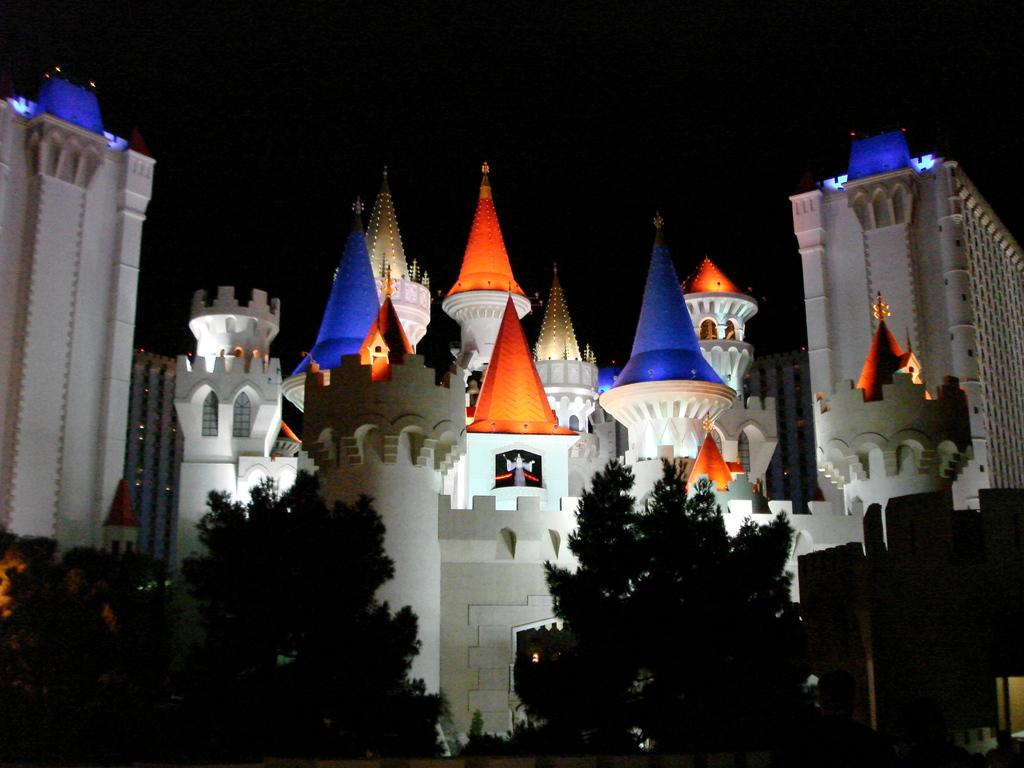What type of structures can be seen in the image? There are buildings in the image. What type of vegetation is present in the image? There are trees in the image. How would you describe the overall lighting in the image? The background of the image is dark. What type of oven can be seen in the image? There is no oven present in the image. What shape is the property in the image? The image does not depict a property, so it is not possible to determine its shape. 